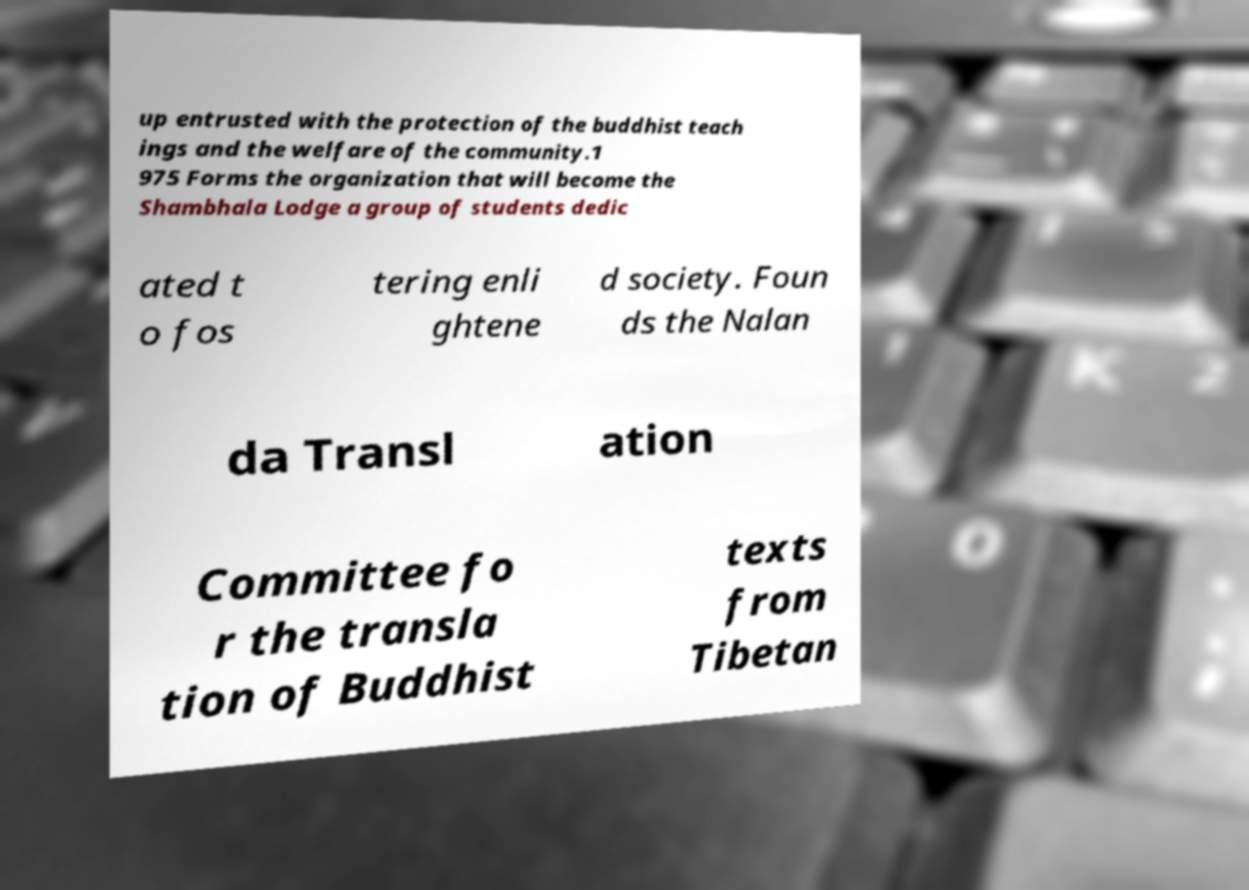Can you accurately transcribe the text from the provided image for me? up entrusted with the protection of the buddhist teach ings and the welfare of the community.1 975 Forms the organization that will become the Shambhala Lodge a group of students dedic ated t o fos tering enli ghtene d society. Foun ds the Nalan da Transl ation Committee fo r the transla tion of Buddhist texts from Tibetan 